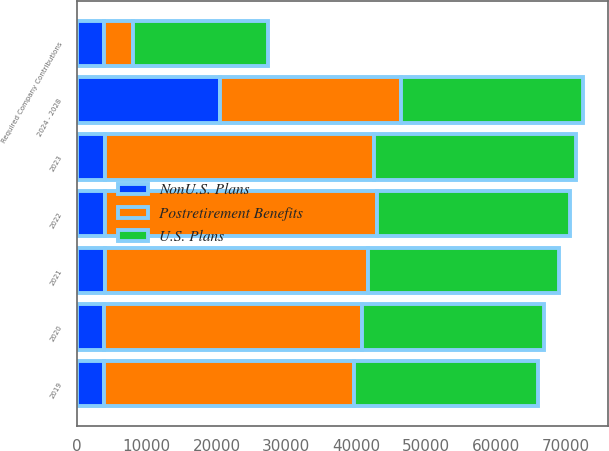<chart> <loc_0><loc_0><loc_500><loc_500><stacked_bar_chart><ecel><fcel>2019<fcel>2020<fcel>2021<fcel>2022<fcel>2023<fcel>2024 - 2028<fcel>Required Company Contributions<nl><fcel>Postretirement Benefits<fcel>35742<fcel>36918<fcel>37710<fcel>38823<fcel>38449<fcel>25991<fcel>4207<nl><fcel>U.S. Plans<fcel>26342<fcel>25991<fcel>27270<fcel>27589<fcel>28843<fcel>25991<fcel>19258<nl><fcel>NonU.S. Plans<fcel>3881<fcel>3940<fcel>4014<fcel>4081<fcel>4085<fcel>20449<fcel>3882<nl></chart> 